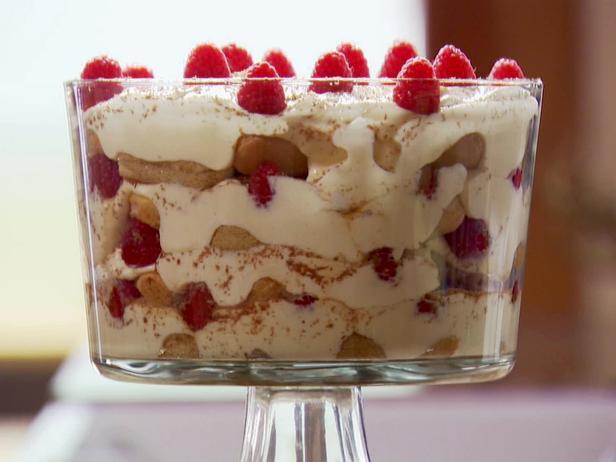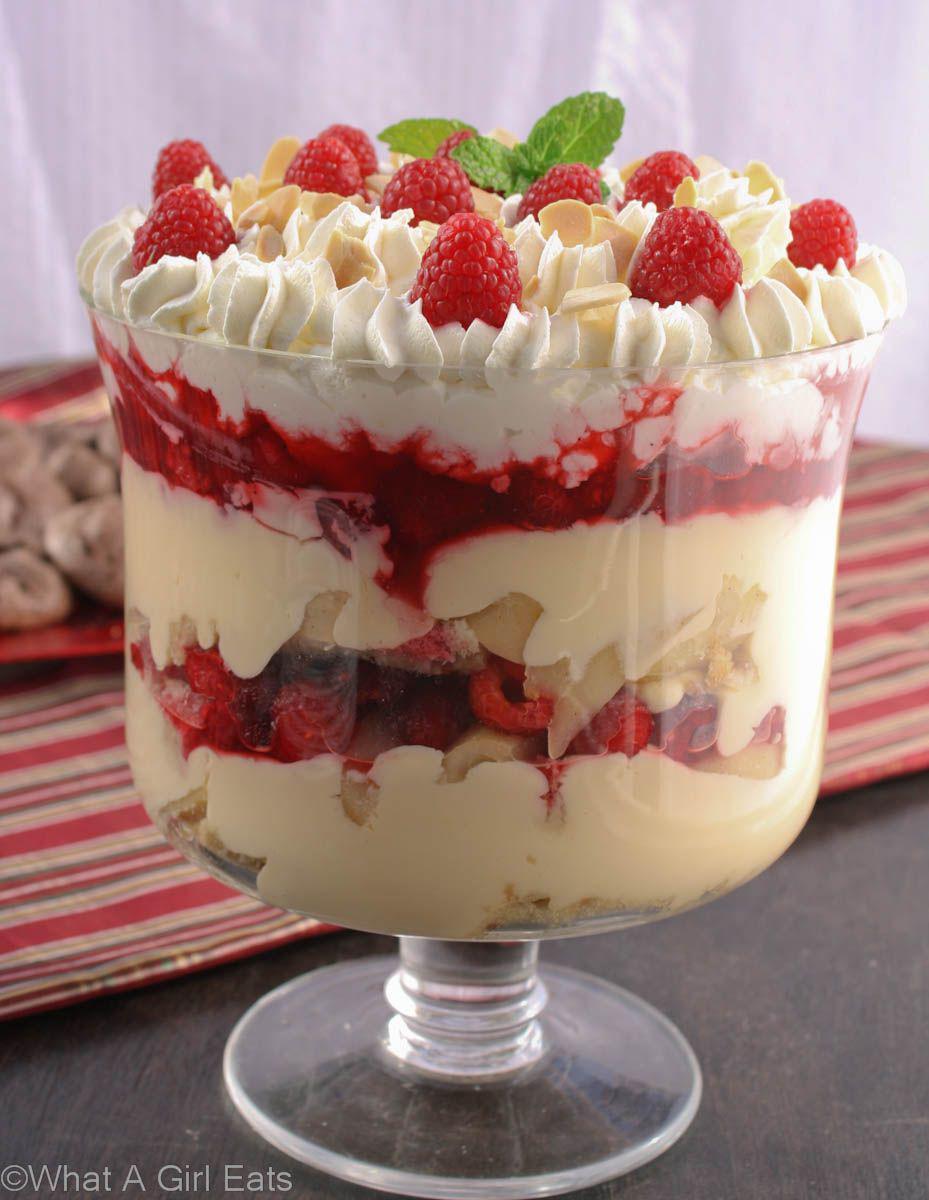The first image is the image on the left, the second image is the image on the right. Assess this claim about the two images: "There are two layered desserts in visibly stemmed cups.". Correct or not? Answer yes or no. Yes. The first image is the image on the left, the second image is the image on the right. Analyze the images presented: Is the assertion "At least one dessert is topped with brown shavings and served in a footed glass." valid? Answer yes or no. No. 